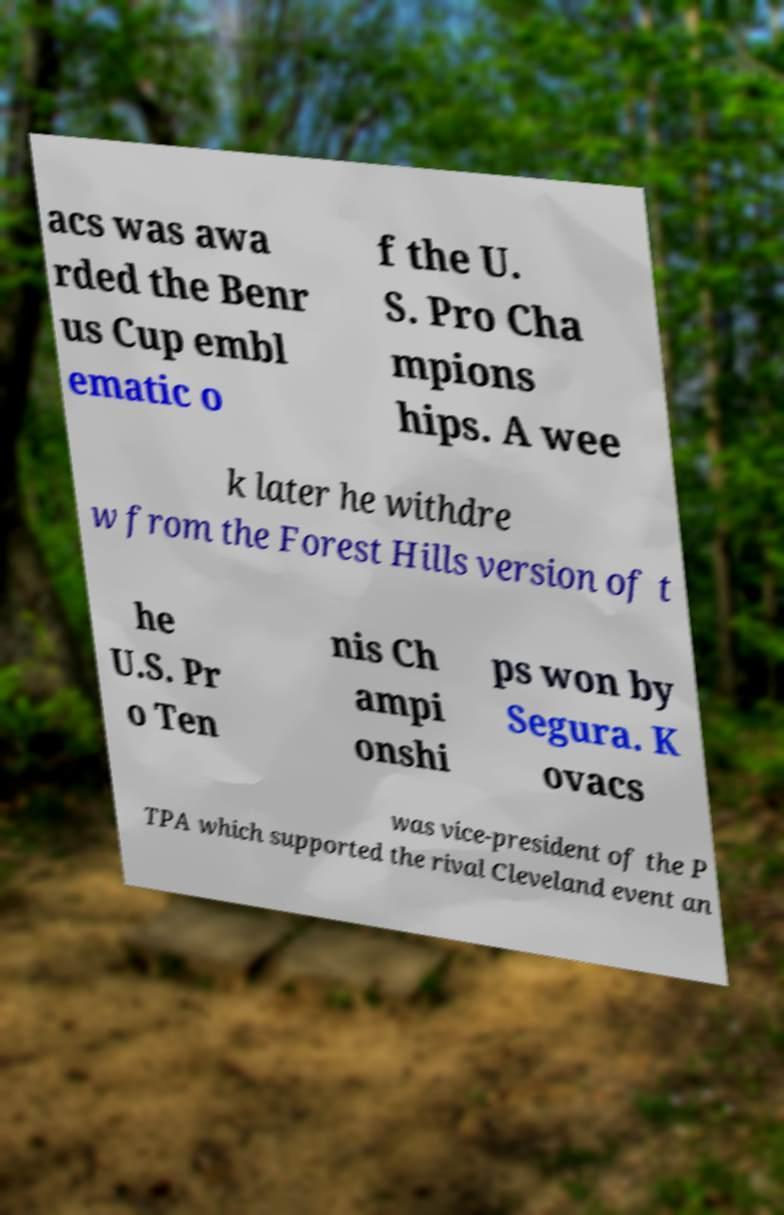For documentation purposes, I need the text within this image transcribed. Could you provide that? acs was awa rded the Benr us Cup embl ematic o f the U. S. Pro Cha mpions hips. A wee k later he withdre w from the Forest Hills version of t he U.S. Pr o Ten nis Ch ampi onshi ps won by Segura. K ovacs was vice-president of the P TPA which supported the rival Cleveland event an 